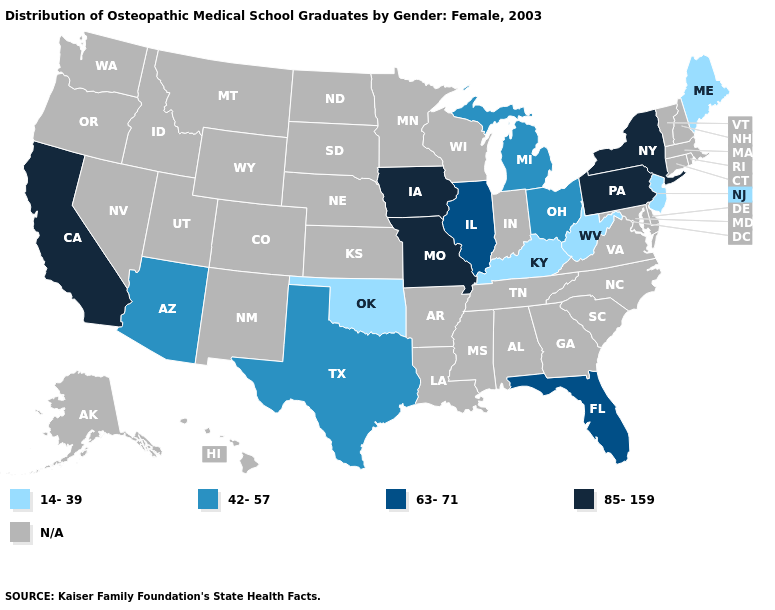Which states have the lowest value in the South?
Give a very brief answer. Kentucky, Oklahoma, West Virginia. What is the value of Washington?
Answer briefly. N/A. What is the value of Wyoming?
Give a very brief answer. N/A. Name the states that have a value in the range 63-71?
Be succinct. Florida, Illinois. What is the value of Colorado?
Be succinct. N/A. Name the states that have a value in the range 42-57?
Give a very brief answer. Arizona, Michigan, Ohio, Texas. What is the value of New Hampshire?
Answer briefly. N/A. What is the lowest value in the MidWest?
Be succinct. 42-57. Which states have the lowest value in the South?
Be succinct. Kentucky, Oklahoma, West Virginia. What is the value of Alaska?
Concise answer only. N/A. Does the map have missing data?
Write a very short answer. Yes. What is the lowest value in the USA?
Give a very brief answer. 14-39. 